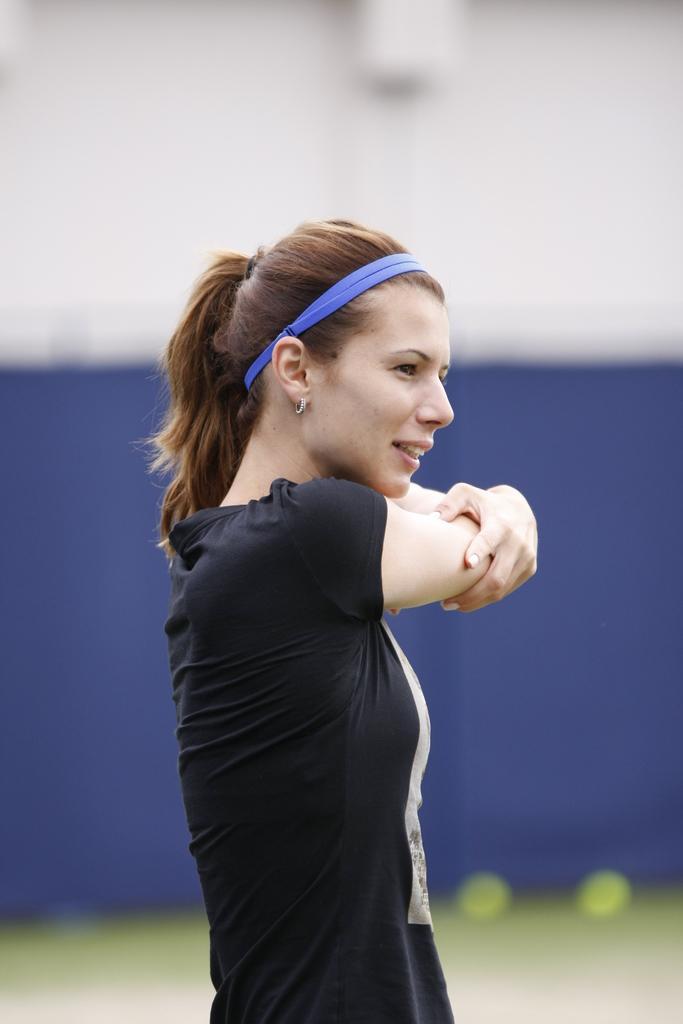Could you give a brief overview of what you see in this image? In this image we can see a lady person wearing black color dress doing exercise and also wearing blue color ribbon to the head and at the background of the image we can see blue color sheet. 